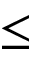Convert formula to latex. <formula><loc_0><loc_0><loc_500><loc_500>\leq</formula> 